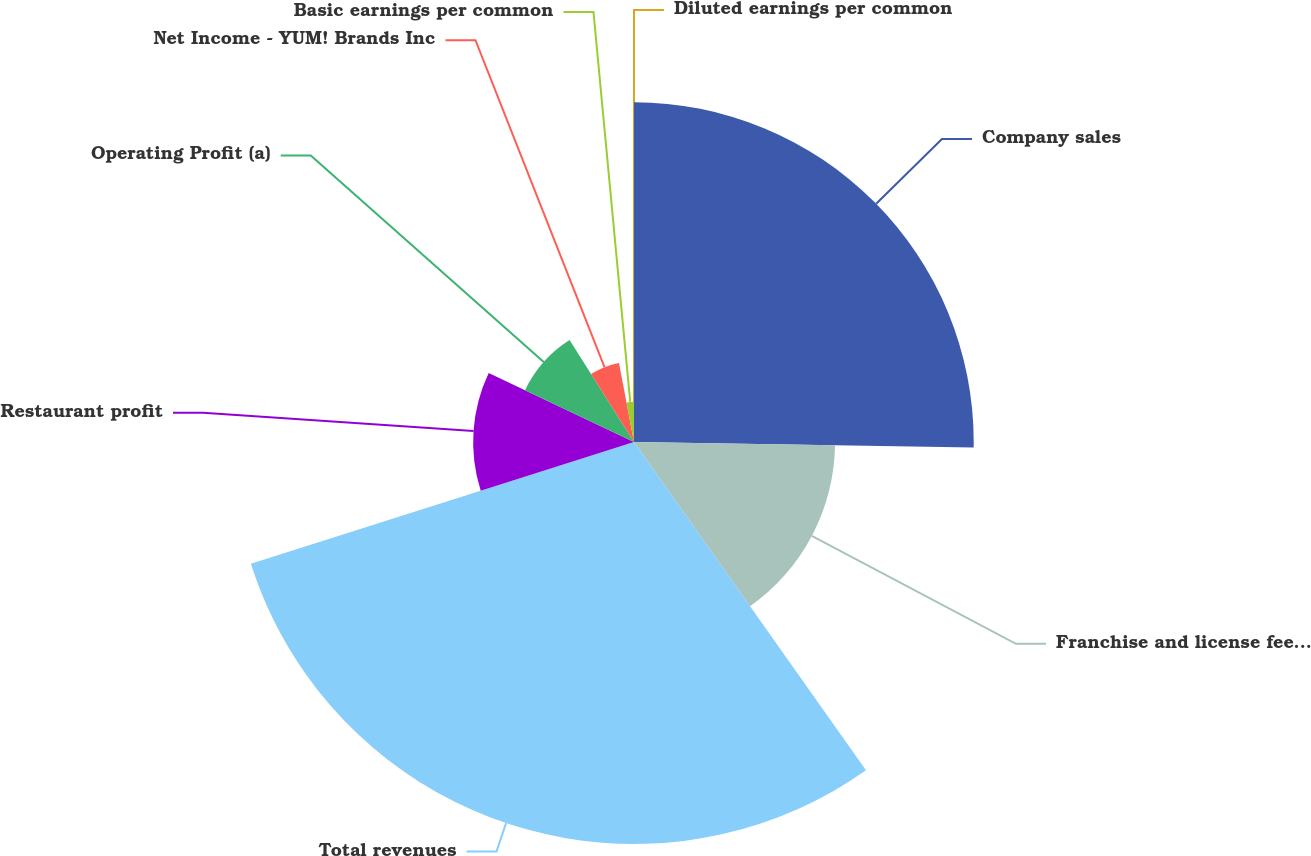Convert chart to OTSL. <chart><loc_0><loc_0><loc_500><loc_500><pie_chart><fcel>Company sales<fcel>Franchise and license fees and<fcel>Total revenues<fcel>Restaurant profit<fcel>Operating Profit (a)<fcel>Net Income - YUM! Brands Inc<fcel>Basic earnings per common<fcel>Diluted earnings per common<nl><fcel>25.26%<fcel>14.95%<fcel>29.89%<fcel>11.96%<fcel>8.97%<fcel>5.98%<fcel>2.99%<fcel>0.0%<nl></chart> 